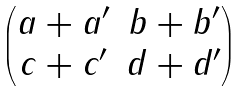<formula> <loc_0><loc_0><loc_500><loc_500>\begin{pmatrix} a + a ^ { \prime } & b + b ^ { \prime } \\ c + c ^ { \prime } & d + d ^ { \prime } \end{pmatrix}</formula> 